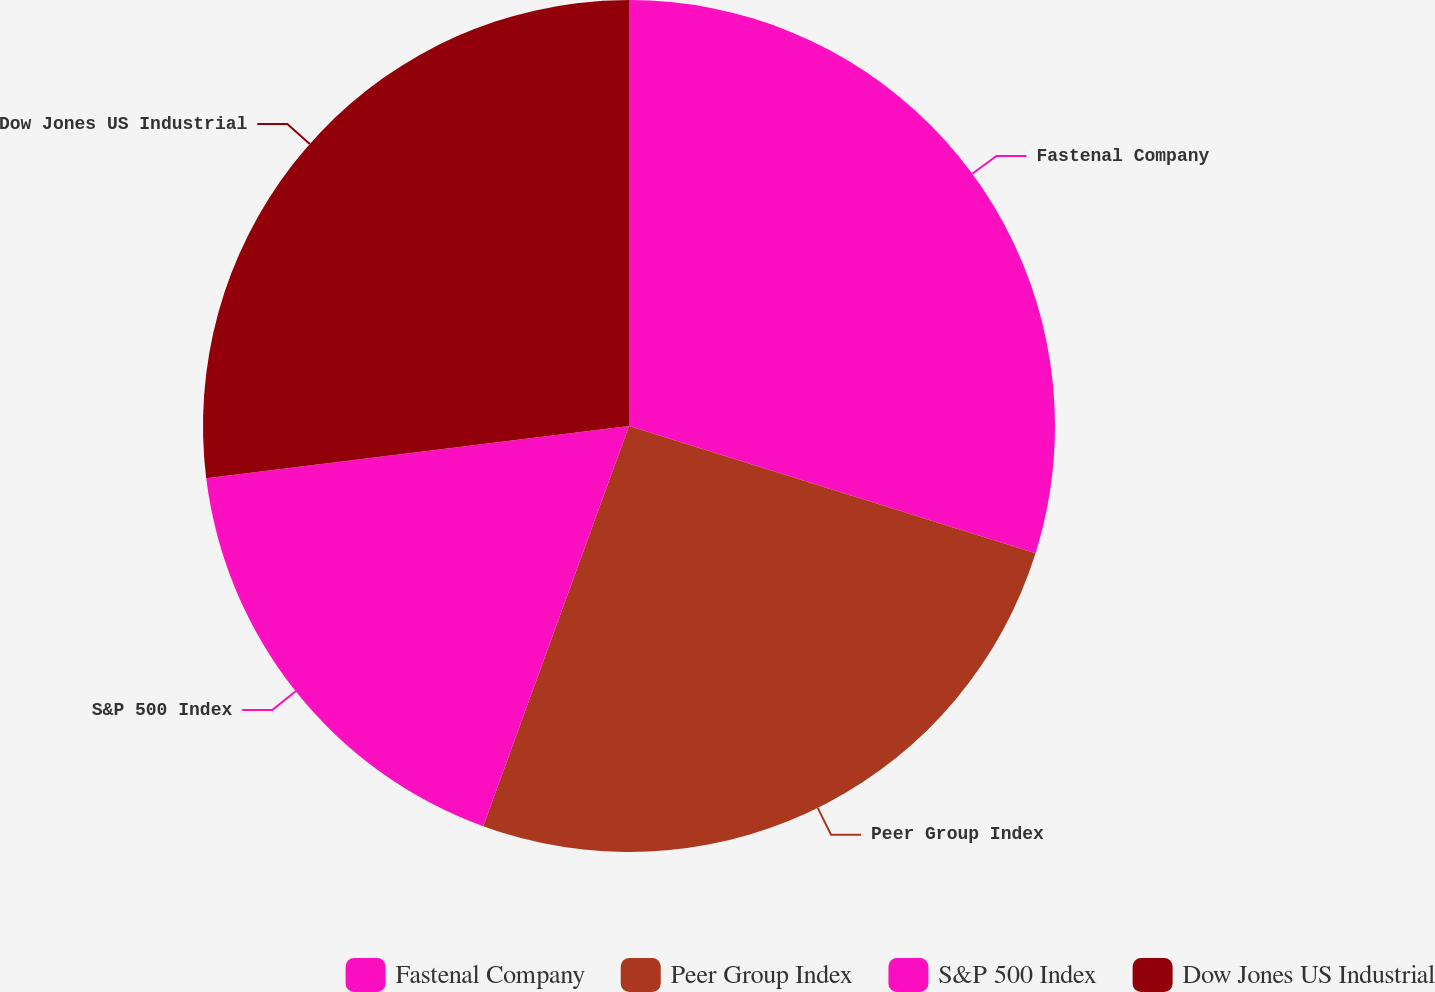<chart> <loc_0><loc_0><loc_500><loc_500><pie_chart><fcel>Fastenal Company<fcel>Peer Group Index<fcel>S&P 500 Index<fcel>Dow Jones US Industrial<nl><fcel>29.83%<fcel>25.73%<fcel>17.48%<fcel>26.96%<nl></chart> 